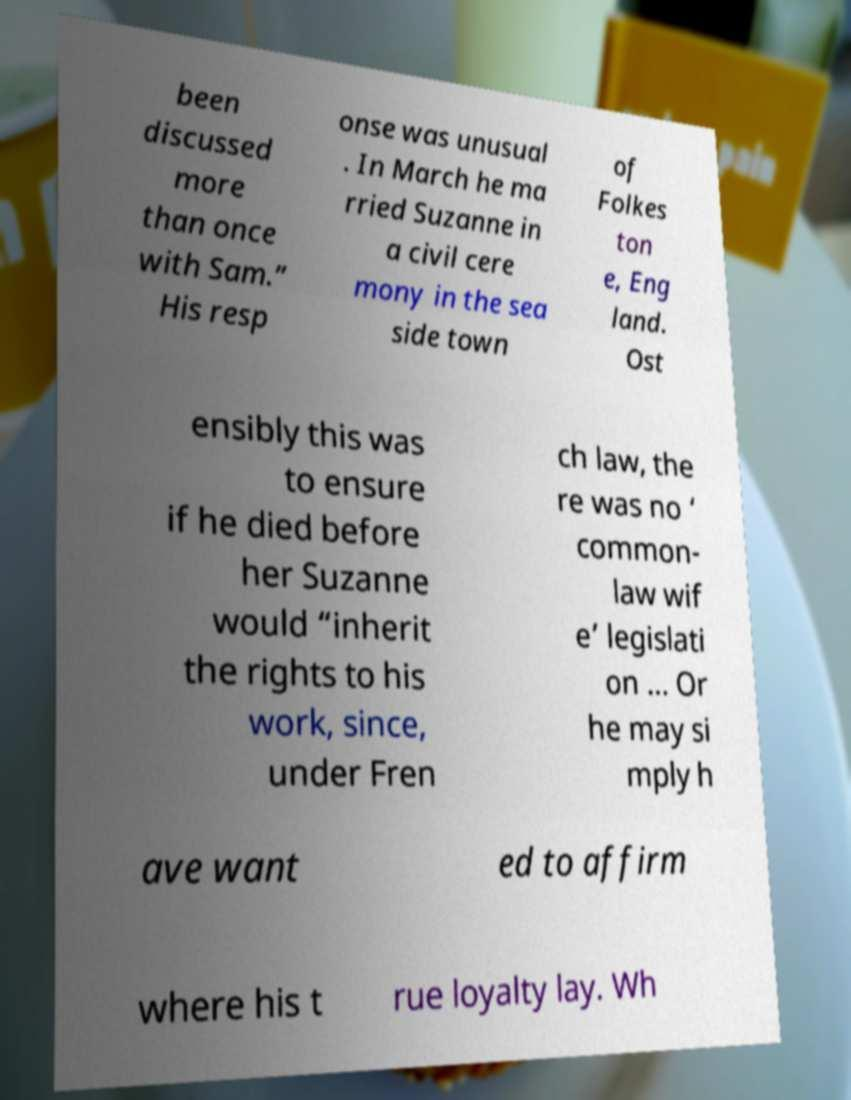Can you accurately transcribe the text from the provided image for me? been discussed more than once with Sam.” His resp onse was unusual . In March he ma rried Suzanne in a civil cere mony in the sea side town of Folkes ton e, Eng land. Ost ensibly this was to ensure if he died before her Suzanne would “inherit the rights to his work, since, under Fren ch law, the re was no ‘ common- law wif e’ legislati on … Or he may si mply h ave want ed to affirm where his t rue loyalty lay. Wh 